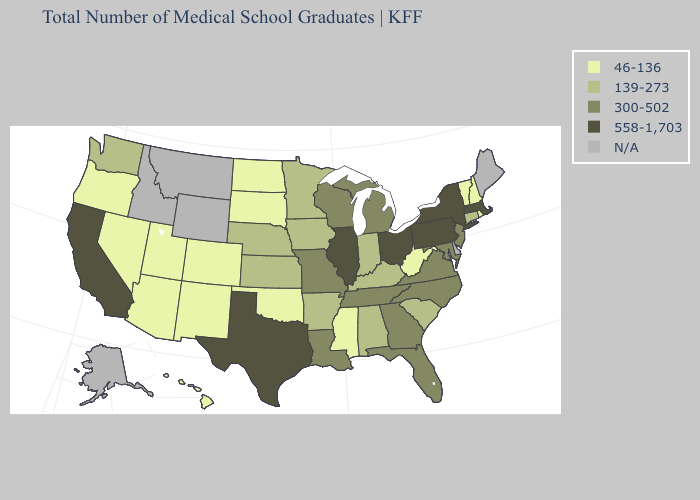Which states have the lowest value in the West?
Keep it brief. Arizona, Colorado, Hawaii, Nevada, New Mexico, Oregon, Utah. Among the states that border Missouri , does Iowa have the highest value?
Short answer required. No. Does the map have missing data?
Concise answer only. Yes. What is the value of Texas?
Concise answer only. 558-1,703. Name the states that have a value in the range N/A?
Write a very short answer. Alaska, Delaware, Idaho, Maine, Montana, Wyoming. What is the lowest value in the USA?
Be succinct. 46-136. What is the value of California?
Write a very short answer. 558-1,703. Does Colorado have the lowest value in the USA?
Concise answer only. Yes. What is the value of Wyoming?
Be succinct. N/A. What is the value of Oklahoma?
Be succinct. 46-136. What is the highest value in the USA?
Write a very short answer. 558-1,703. What is the lowest value in states that border Utah?
Concise answer only. 46-136. What is the value of Florida?
Answer briefly. 300-502. Does the first symbol in the legend represent the smallest category?
Quick response, please. Yes. What is the value of North Carolina?
Short answer required. 300-502. 